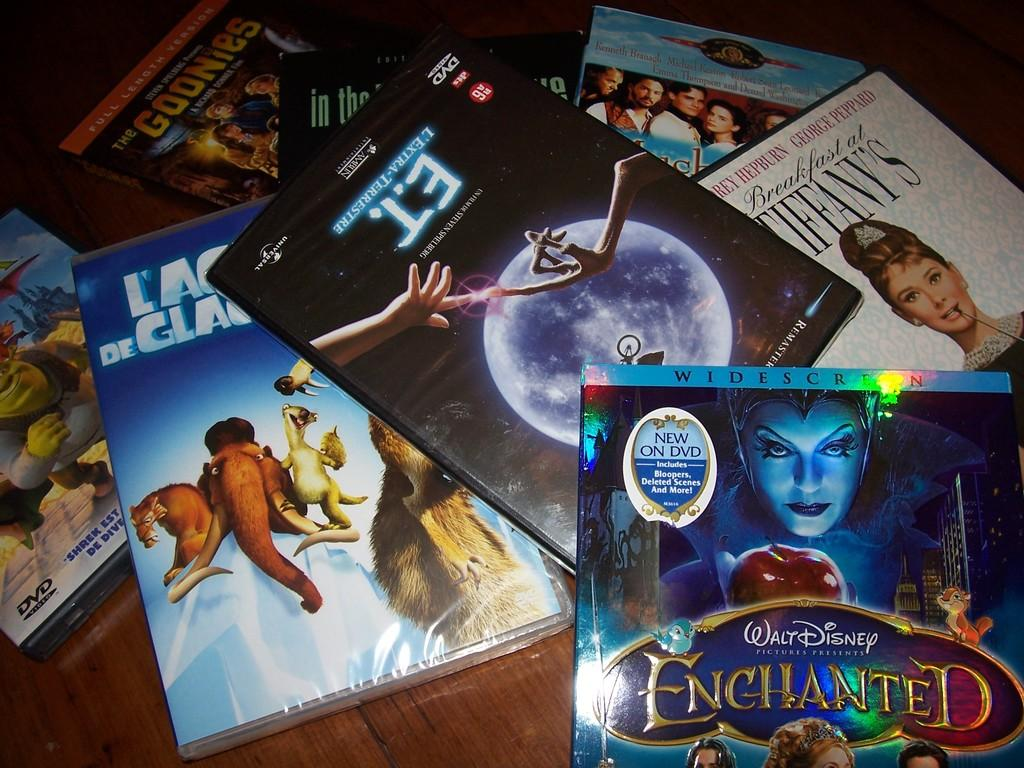What objects are present in the image? There are boxes in the image. Where are the boxes located? The boxes are on a wooden surface. What can be seen on the boxes? There is text and images on the boxes. What type of bottle is being used to hold the cord in the image? There is no bottle or cord present in the image; it only features boxes on a wooden surface with text and images. 